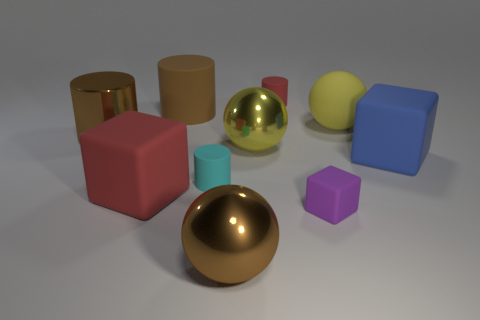Does the large shiny cylinder have the same color as the big rubber cylinder?
Give a very brief answer. Yes. The blue object has what shape?
Provide a short and direct response. Cube. Is there a large object that has the same color as the matte ball?
Your response must be concise. Yes. Are there more small purple matte things right of the yellow metal ball than purple rubber blocks?
Provide a short and direct response. No. Do the brown matte thing and the small cyan matte thing that is in front of the blue rubber block have the same shape?
Keep it short and to the point. Yes. Are there any large purple cylinders?
Your answer should be compact. No. How many big things are either yellow shiny cubes or shiny objects?
Offer a terse response. 3. Are there more cylinders that are behind the rubber ball than things that are to the right of the shiny cylinder?
Your answer should be very brief. No. Do the big blue block and the big brown cylinder in front of the brown matte object have the same material?
Give a very brief answer. No. The tiny matte block is what color?
Keep it short and to the point. Purple. 